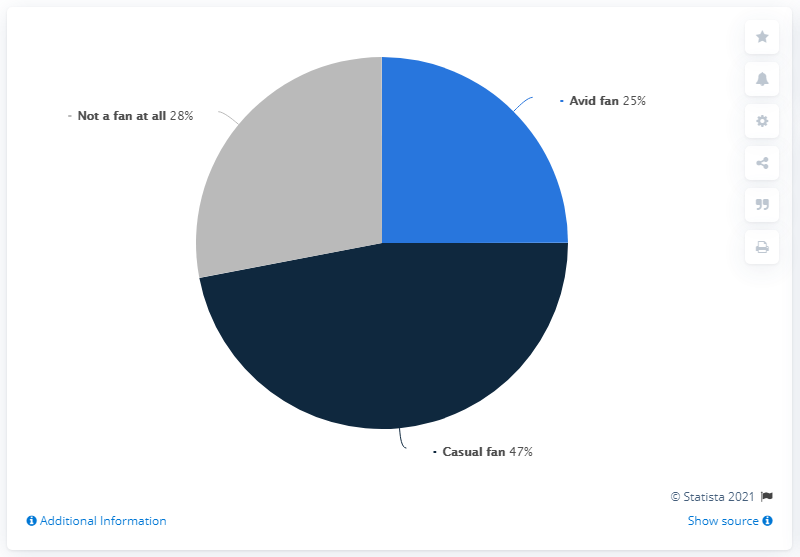Give some essential details in this illustration. According to a recent survey, only 28% of sports fans in the US as of June 2021 declared themselves to be "Not a fan at all. According to a survey conducted in June 2021, 72% of sports fans in the US self-identify as fans. 